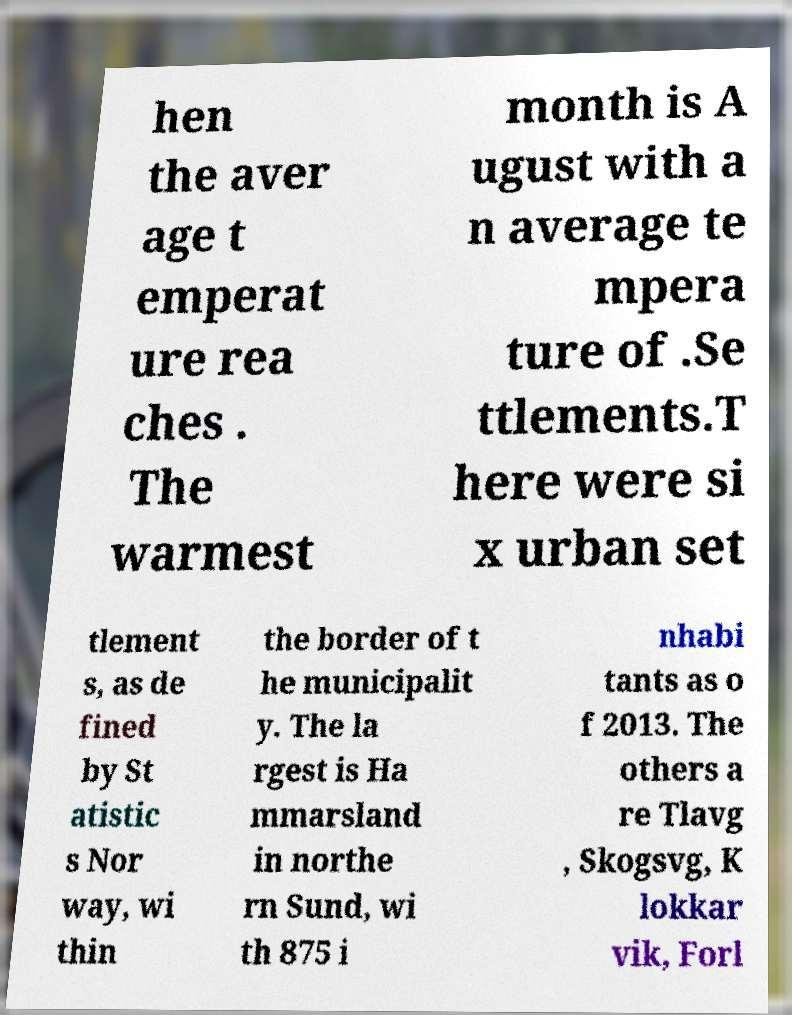Please identify and transcribe the text found in this image. hen the aver age t emperat ure rea ches . The warmest month is A ugust with a n average te mpera ture of .Se ttlements.T here were si x urban set tlement s, as de fined by St atistic s Nor way, wi thin the border of t he municipalit y. The la rgest is Ha mmarsland in northe rn Sund, wi th 875 i nhabi tants as o f 2013. The others a re Tlavg , Skogsvg, K lokkar vik, Forl 